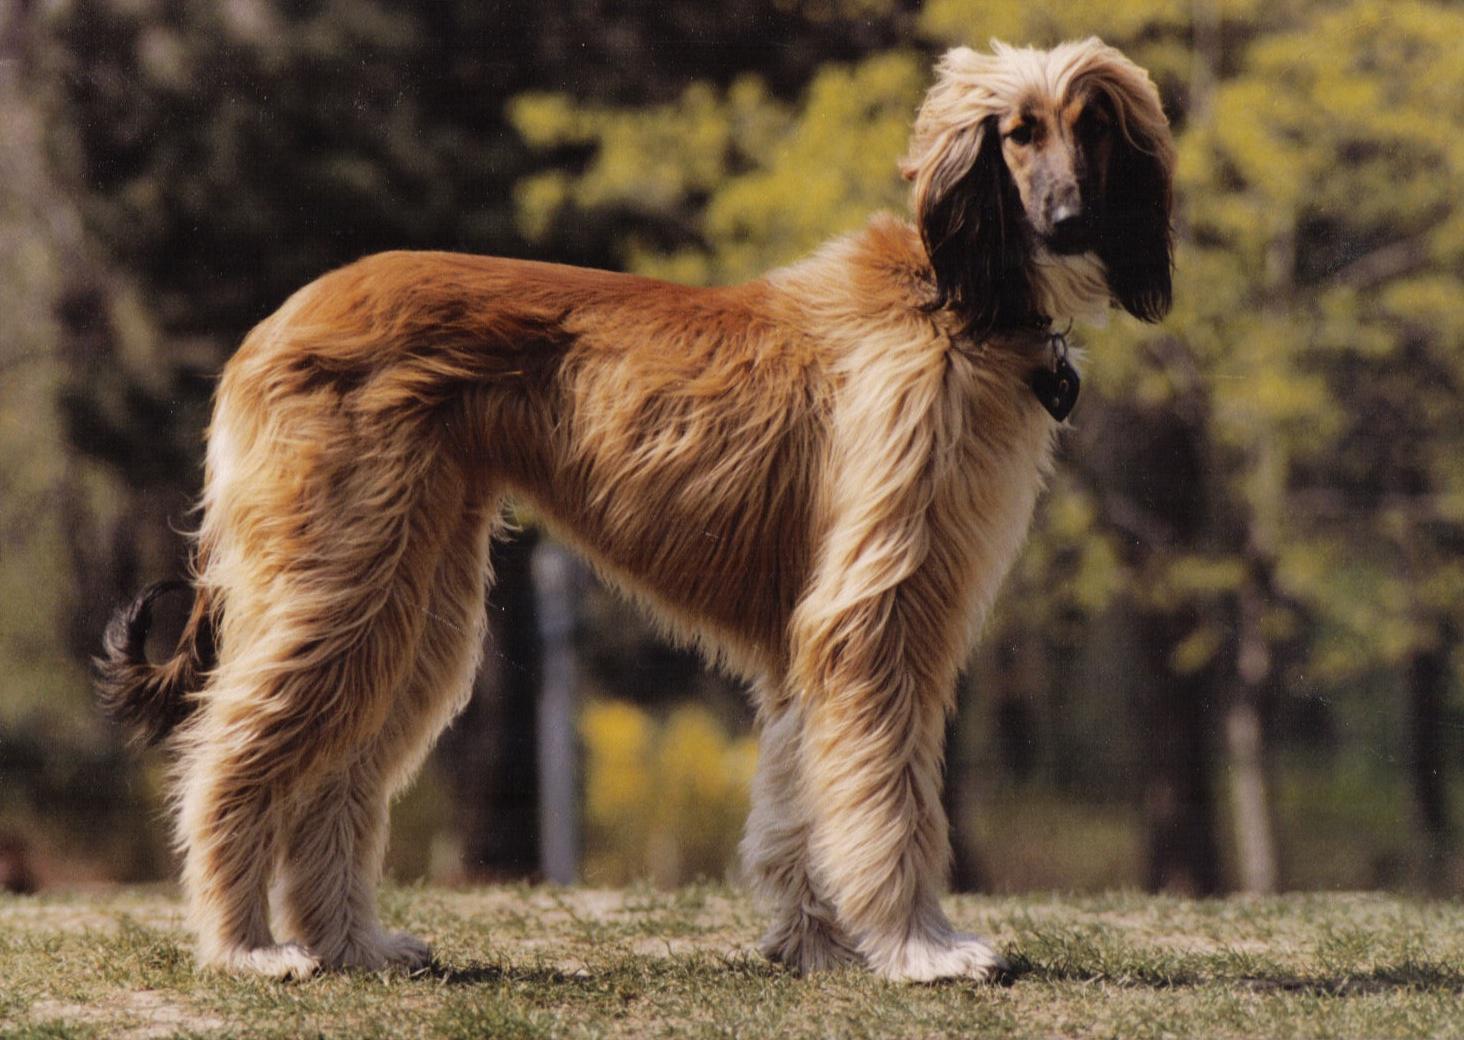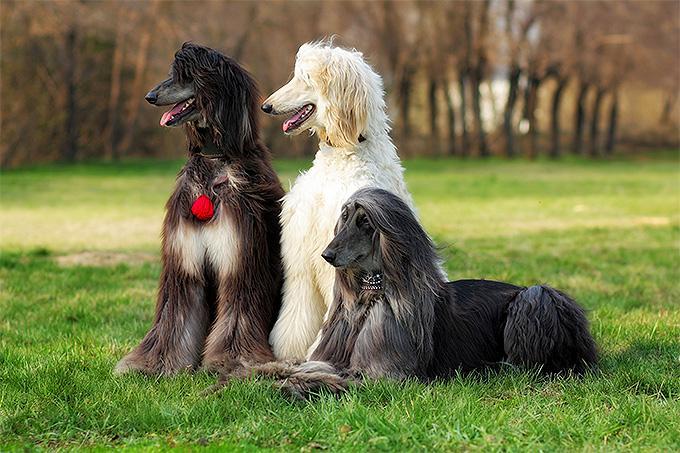The first image is the image on the left, the second image is the image on the right. Examine the images to the left and right. Is the description "At least one image shows a dog bounding across the grass." accurate? Answer yes or no. No. 